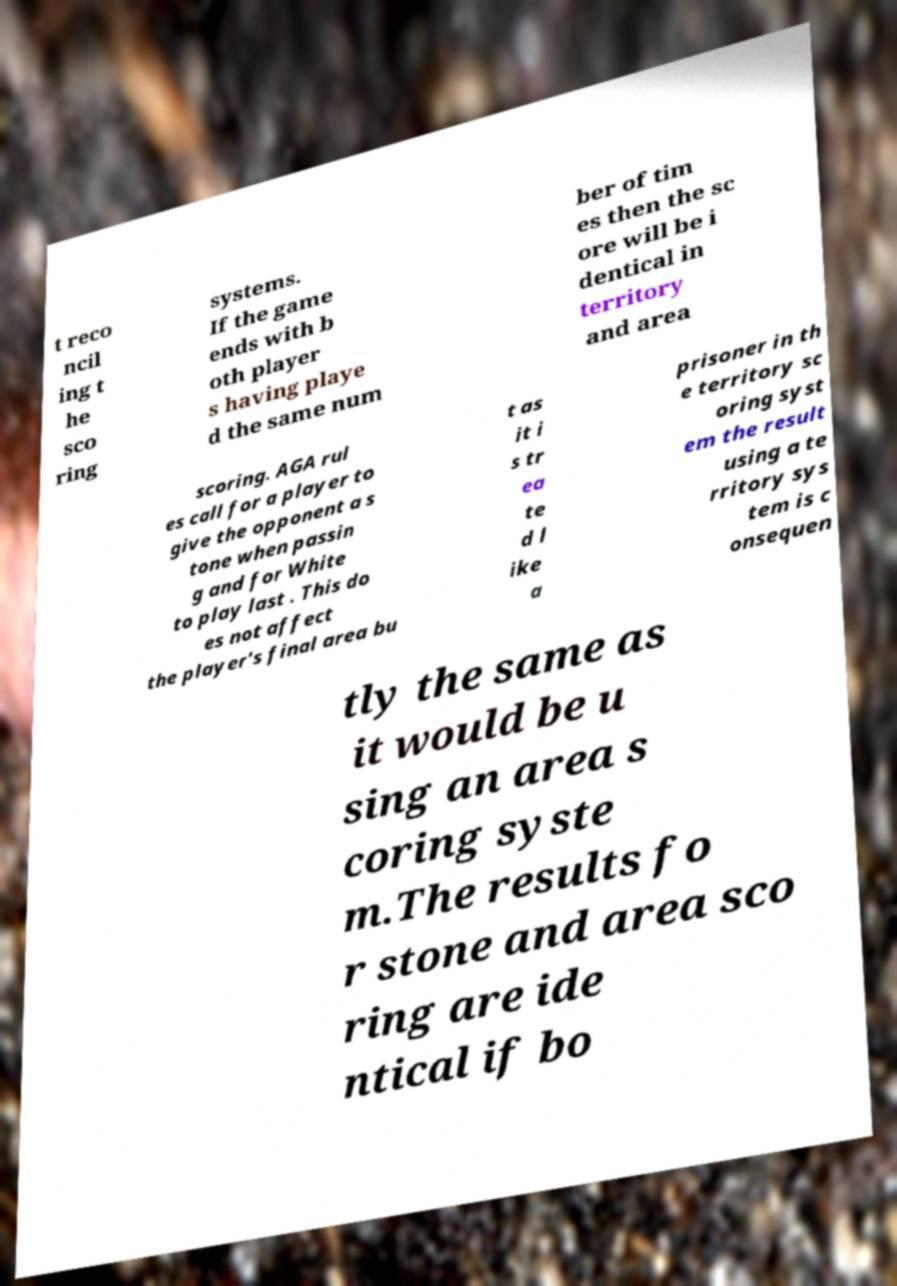There's text embedded in this image that I need extracted. Can you transcribe it verbatim? t reco ncil ing t he sco ring systems. If the game ends with b oth player s having playe d the same num ber of tim es then the sc ore will be i dentical in territory and area scoring. AGA rul es call for a player to give the opponent a s tone when passin g and for White to play last . This do es not affect the player's final area bu t as it i s tr ea te d l ike a prisoner in th e territory sc oring syst em the result using a te rritory sys tem is c onsequen tly the same as it would be u sing an area s coring syste m.The results fo r stone and area sco ring are ide ntical if bo 